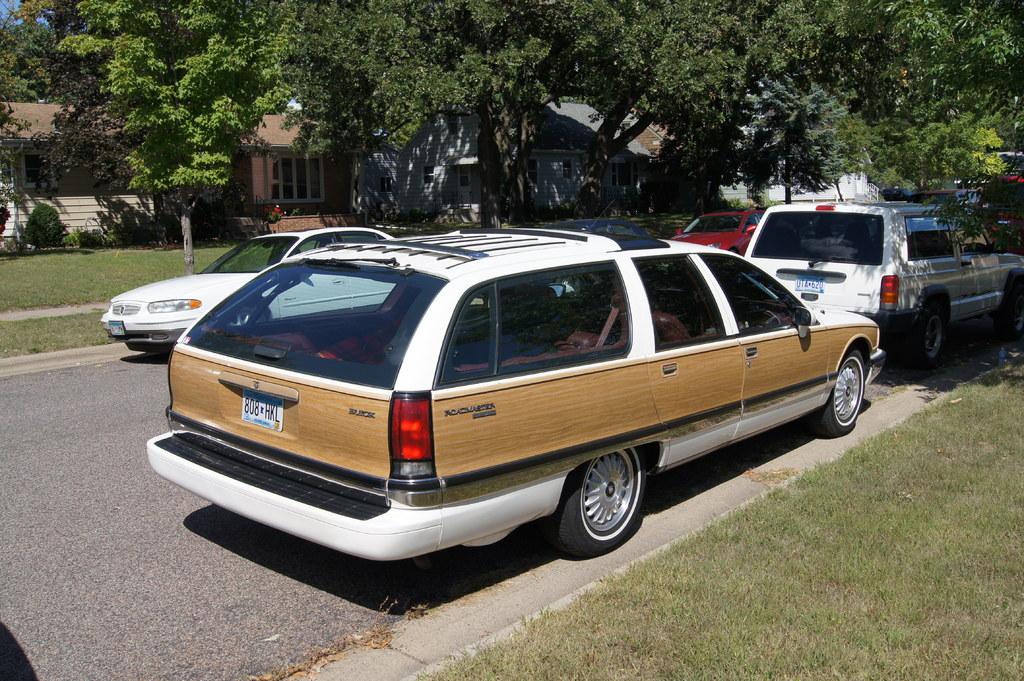What is the make of this car?
Offer a terse response. Buick. What is the plate number?
Ensure brevity in your answer.  808 hkl. 